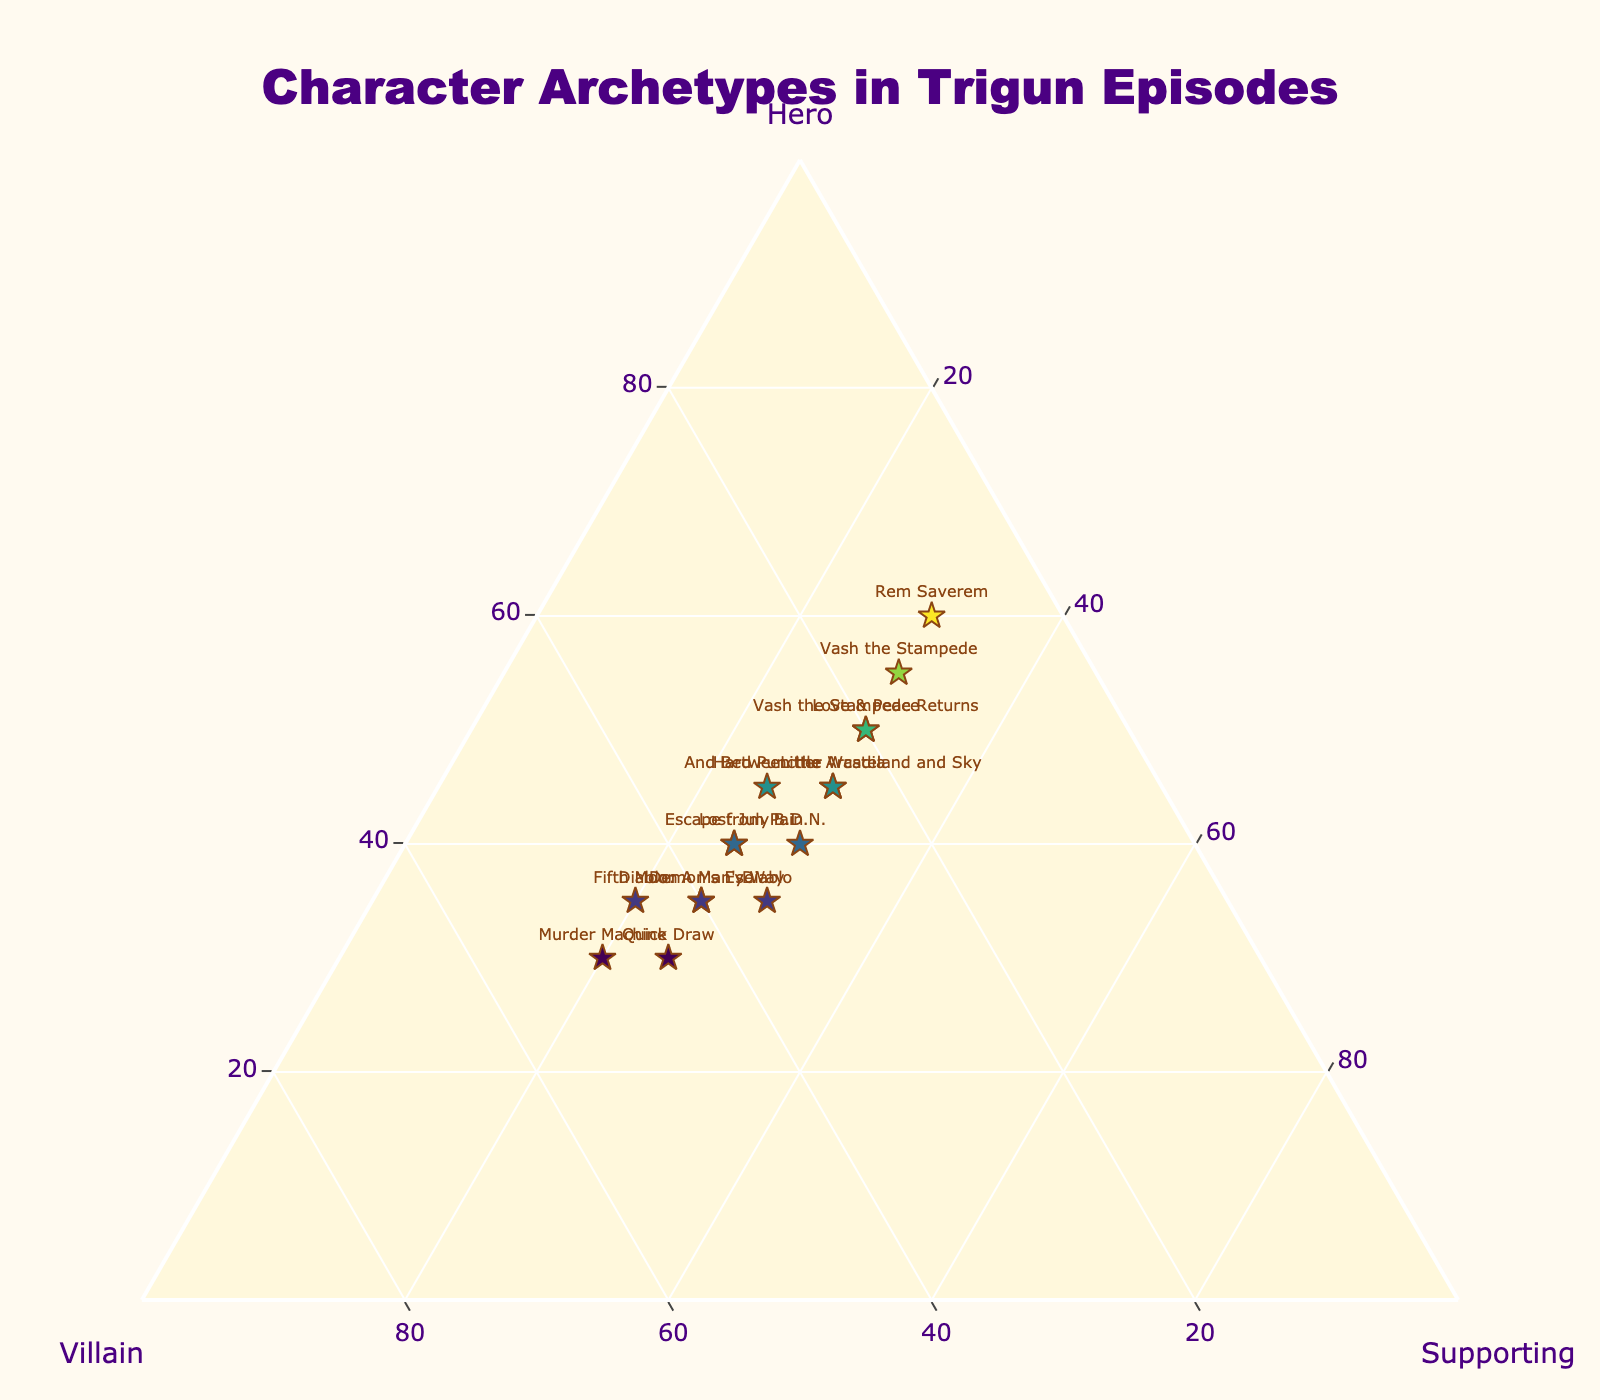What's the title of the figure? The title is located at the top of the figure. It provides a brief description of what the visual represents. By referring to the top of the figure, we see the title "Character Archetypes in Trigun Episodes."
Answer: "Character Archetypes in Trigun Episodes" How many episodes are plotted in the figure? Count the number of labeled data points on the ternary plot. Each label represents an episode. By counting all labeled data points, we find there are 15 episodes.
Answer: 15 Which episode has the highest proportion of Heroes? Identify the data point furthest along the 'Hero' axis. The episode "Rem Saverem" is plotted with a 'Hero' value of 60%, which is the highest among all the episodes.
Answer: "Rem Saverem" What is the median hero value among all episodes? Extract the 'Hero' values for all episodes and sort them in ascending order: (30, 30, 30, 30, 35, 35, 35, 35, 40, 40, 40, 45, 45, 50, 55, 60). With 15 episodes, the median is the 8th value in this sorted list, which is 40.
Answer: 40 Which episodes have an equal proportion of Heroes and Villains? Identify the episodes where the 'Hero' and 'Villain' values are the same. By scanning the data points, "Diablo" and "Escape from Pain" both have 35% 'Hero' and 35% 'Villain'.
Answer: "Diablo" and "Escape from Pain" What is the average proportion of Supporting characters across all episodes? Calculate the mean of the 'Supporting' values. Sum all the 'Supporting' values (25+25+25+30+25+30+30+30+20+30+25+25+30+30+30)= 400 and divide by the number of episodes (15). The average is 400/15 = 26.67%.
Answer: 26.67% Compare "Murder Machine" and "Love & Peace": Which episode has a higher proportion of Villains? Compare the 'Villain' values for the two episodes. "Murder Machine" has a 'Villain' value of 50%, and "Love & Peace" has a 'Villain' value of 20%. Thus, "Murder Machine" has a higher proportion.
Answer: "Murder Machine" Which three episodes have the highest proportion of Supporting characters? Sort the episodes by their 'Supporting' values. The three highest values are all 30%, corresponding to "Love & Peace," "Diablo," "B.D.N.," "And Between the Wasteland and Sky," "Vash the Stampede," "Vash the Stampede Returns," and "Little Arcadia." All these episodes have the same highest 'Supporting' value.
Answer: "Love & Peace," "Diablo," "B.D.N.," "And Between the Wasteland and Sky," "Vash the Stampede," "Vash the Stampede Returns," and "Little Arcadia" What's the difference in the proportion of Heroes between "Lost July" and "Diablo: A Man's Way"? Find the Hero values for both episodes: "Lost July" with 40% and "Diablo: A Man's Way" with 35%. The difference is 40% - 35% = 5%.
Answer: 5% 